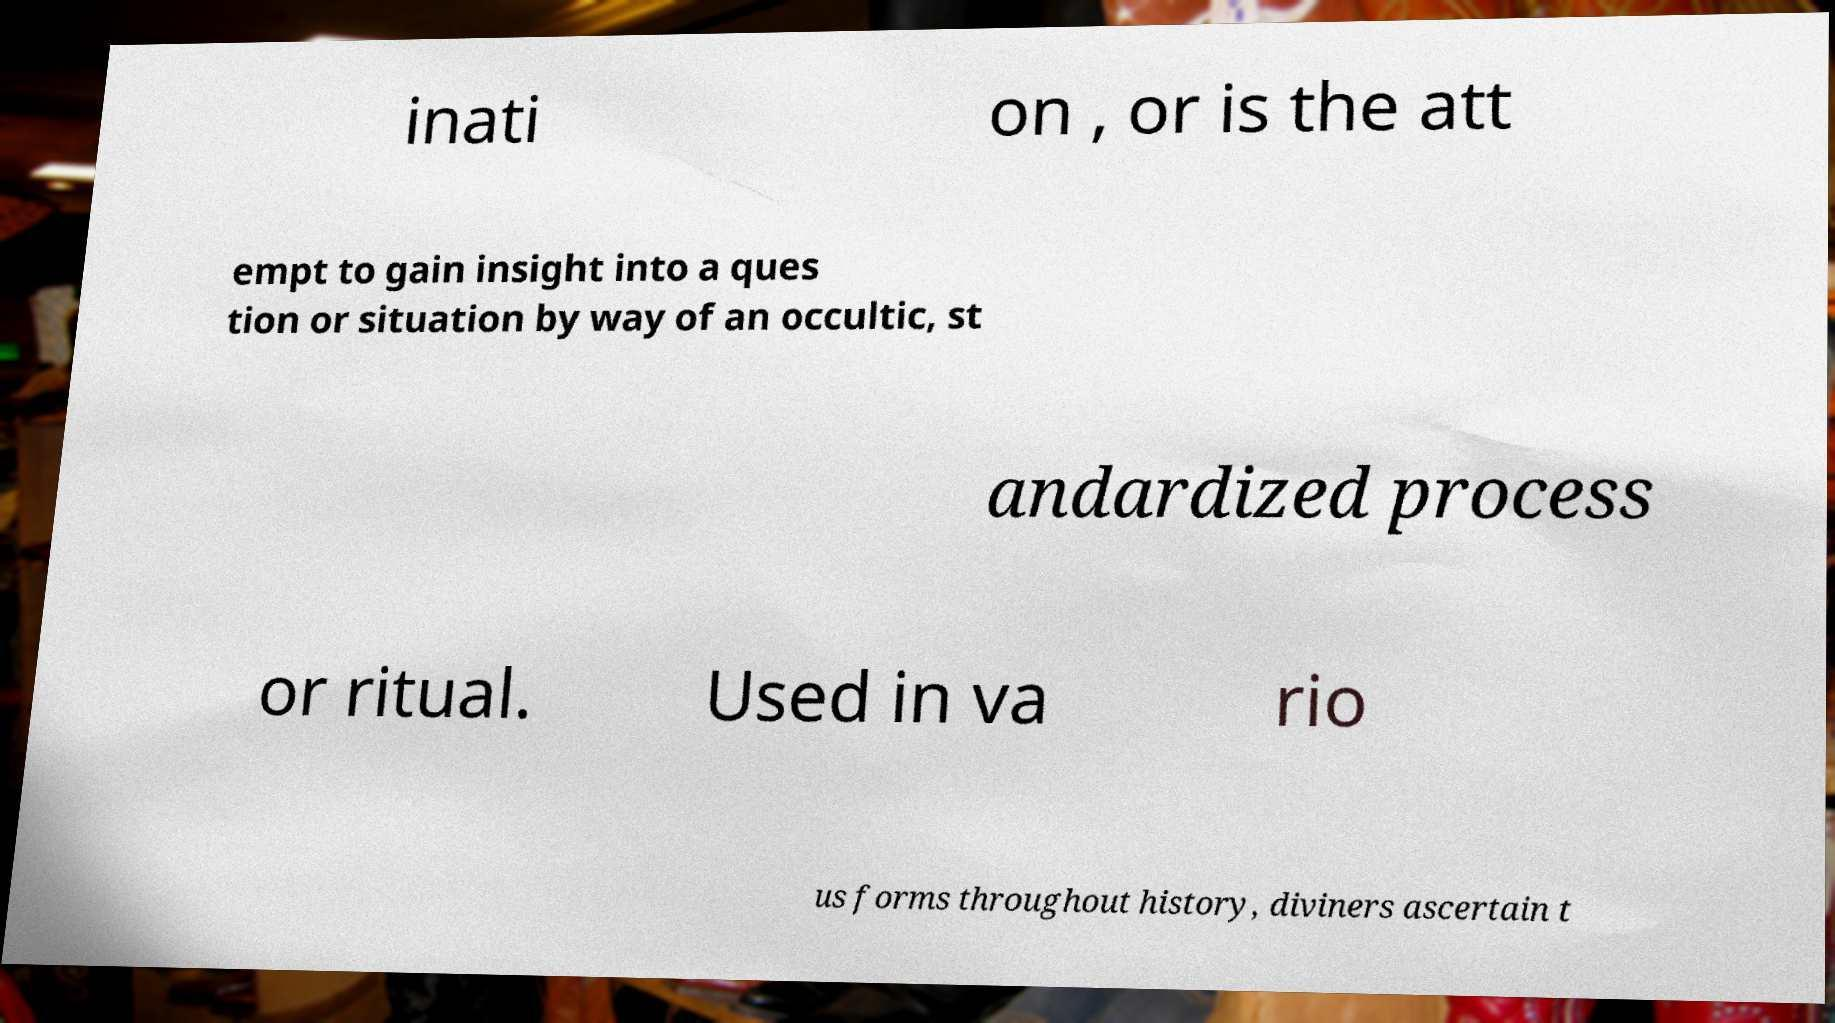What messages or text are displayed in this image? I need them in a readable, typed format. inati on , or is the att empt to gain insight into a ques tion or situation by way of an occultic, st andardized process or ritual. Used in va rio us forms throughout history, diviners ascertain t 